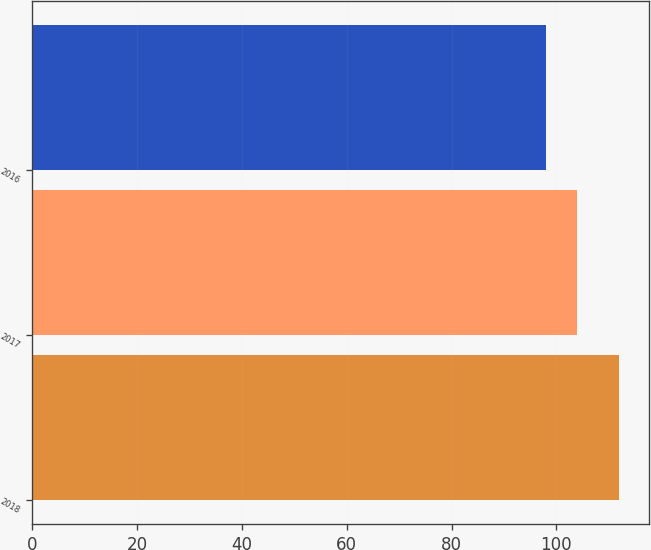Convert chart to OTSL. <chart><loc_0><loc_0><loc_500><loc_500><bar_chart><fcel>2018<fcel>2017<fcel>2016<nl><fcel>112<fcel>104<fcel>98<nl></chart> 